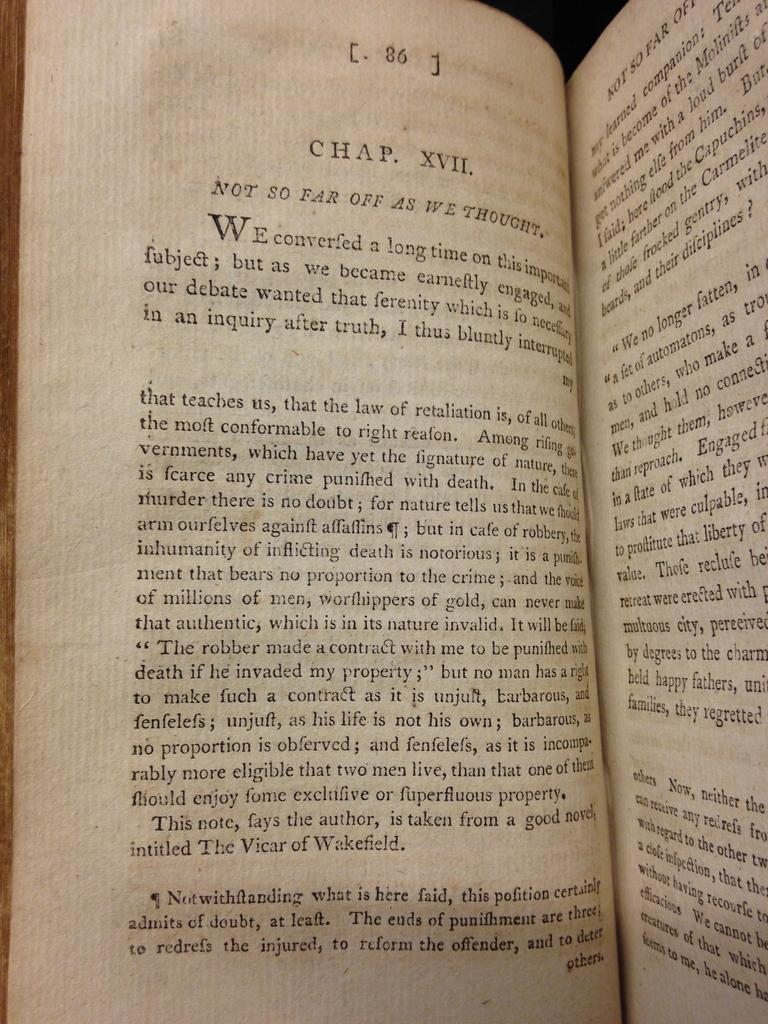What is the main object in the foreground of the image? There is a book in the foreground of the image. What can be found on the book? There is text on the book. What type of substance is being consumed by the person in the image? There is no person present in the image, and therefore no substance consumption can be observed. 